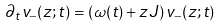<formula> <loc_0><loc_0><loc_500><loc_500>\partial _ { t } v _ { - } ( z ; t ) = \left ( \omega ( t ) + z J \right ) v _ { - } ( z ; t )</formula> 